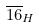<formula> <loc_0><loc_0><loc_500><loc_500>\overline { 1 6 } _ { H }</formula> 